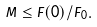Convert formula to latex. <formula><loc_0><loc_0><loc_500><loc_500>M \leq F ( 0 ) / F _ { 0 } .</formula> 